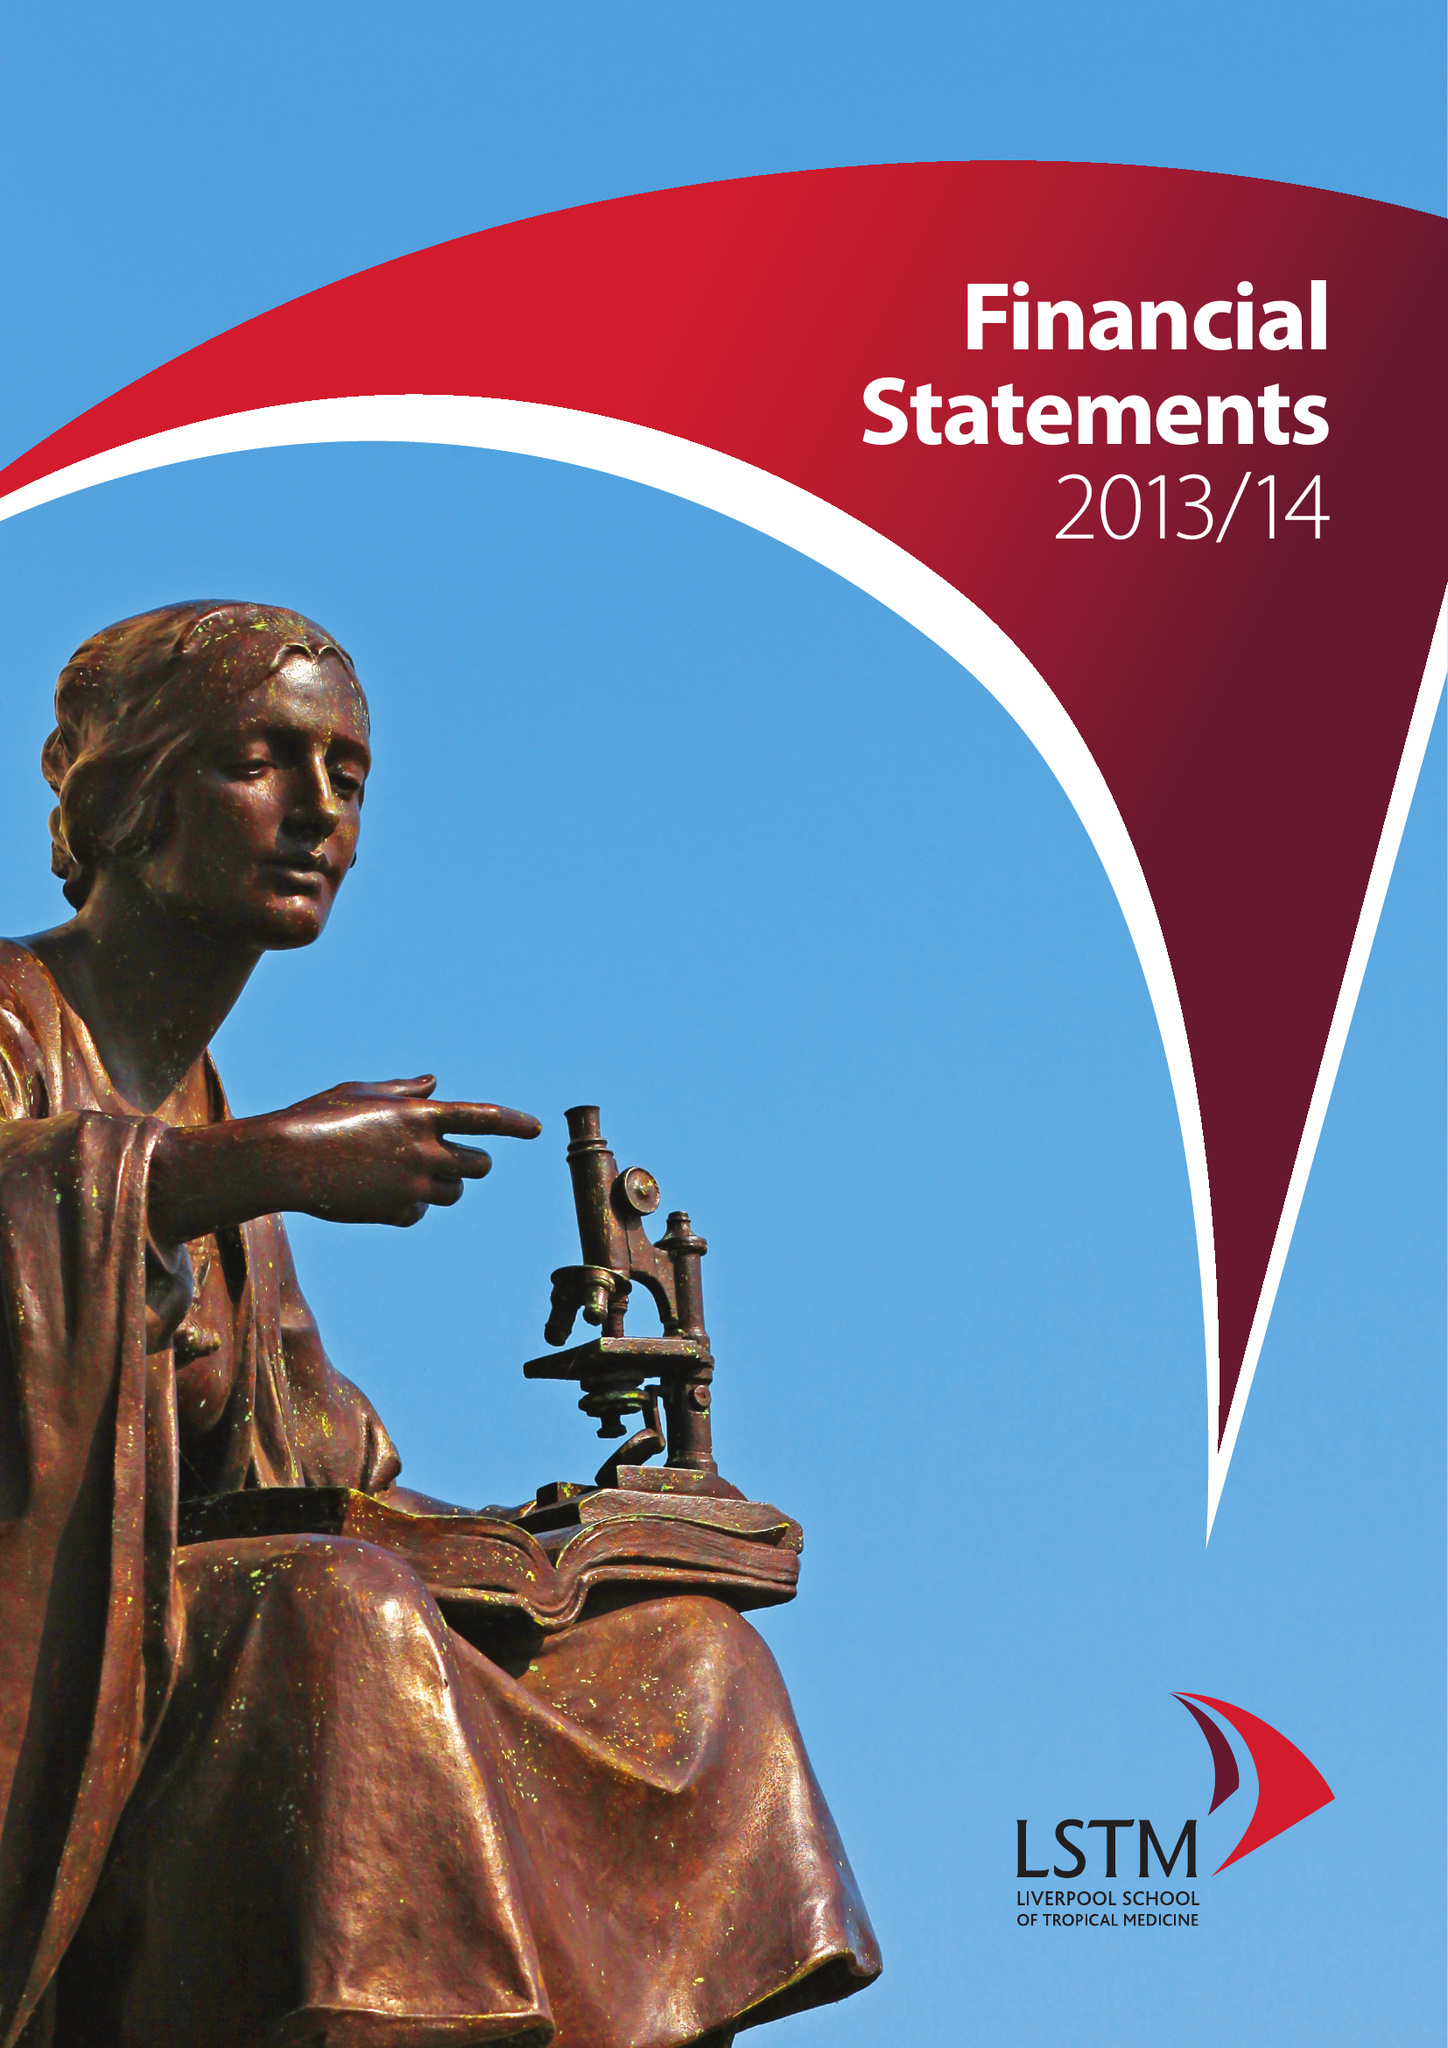What is the value for the spending_annually_in_british_pounds?
Answer the question using a single word or phrase. 63149000.00 